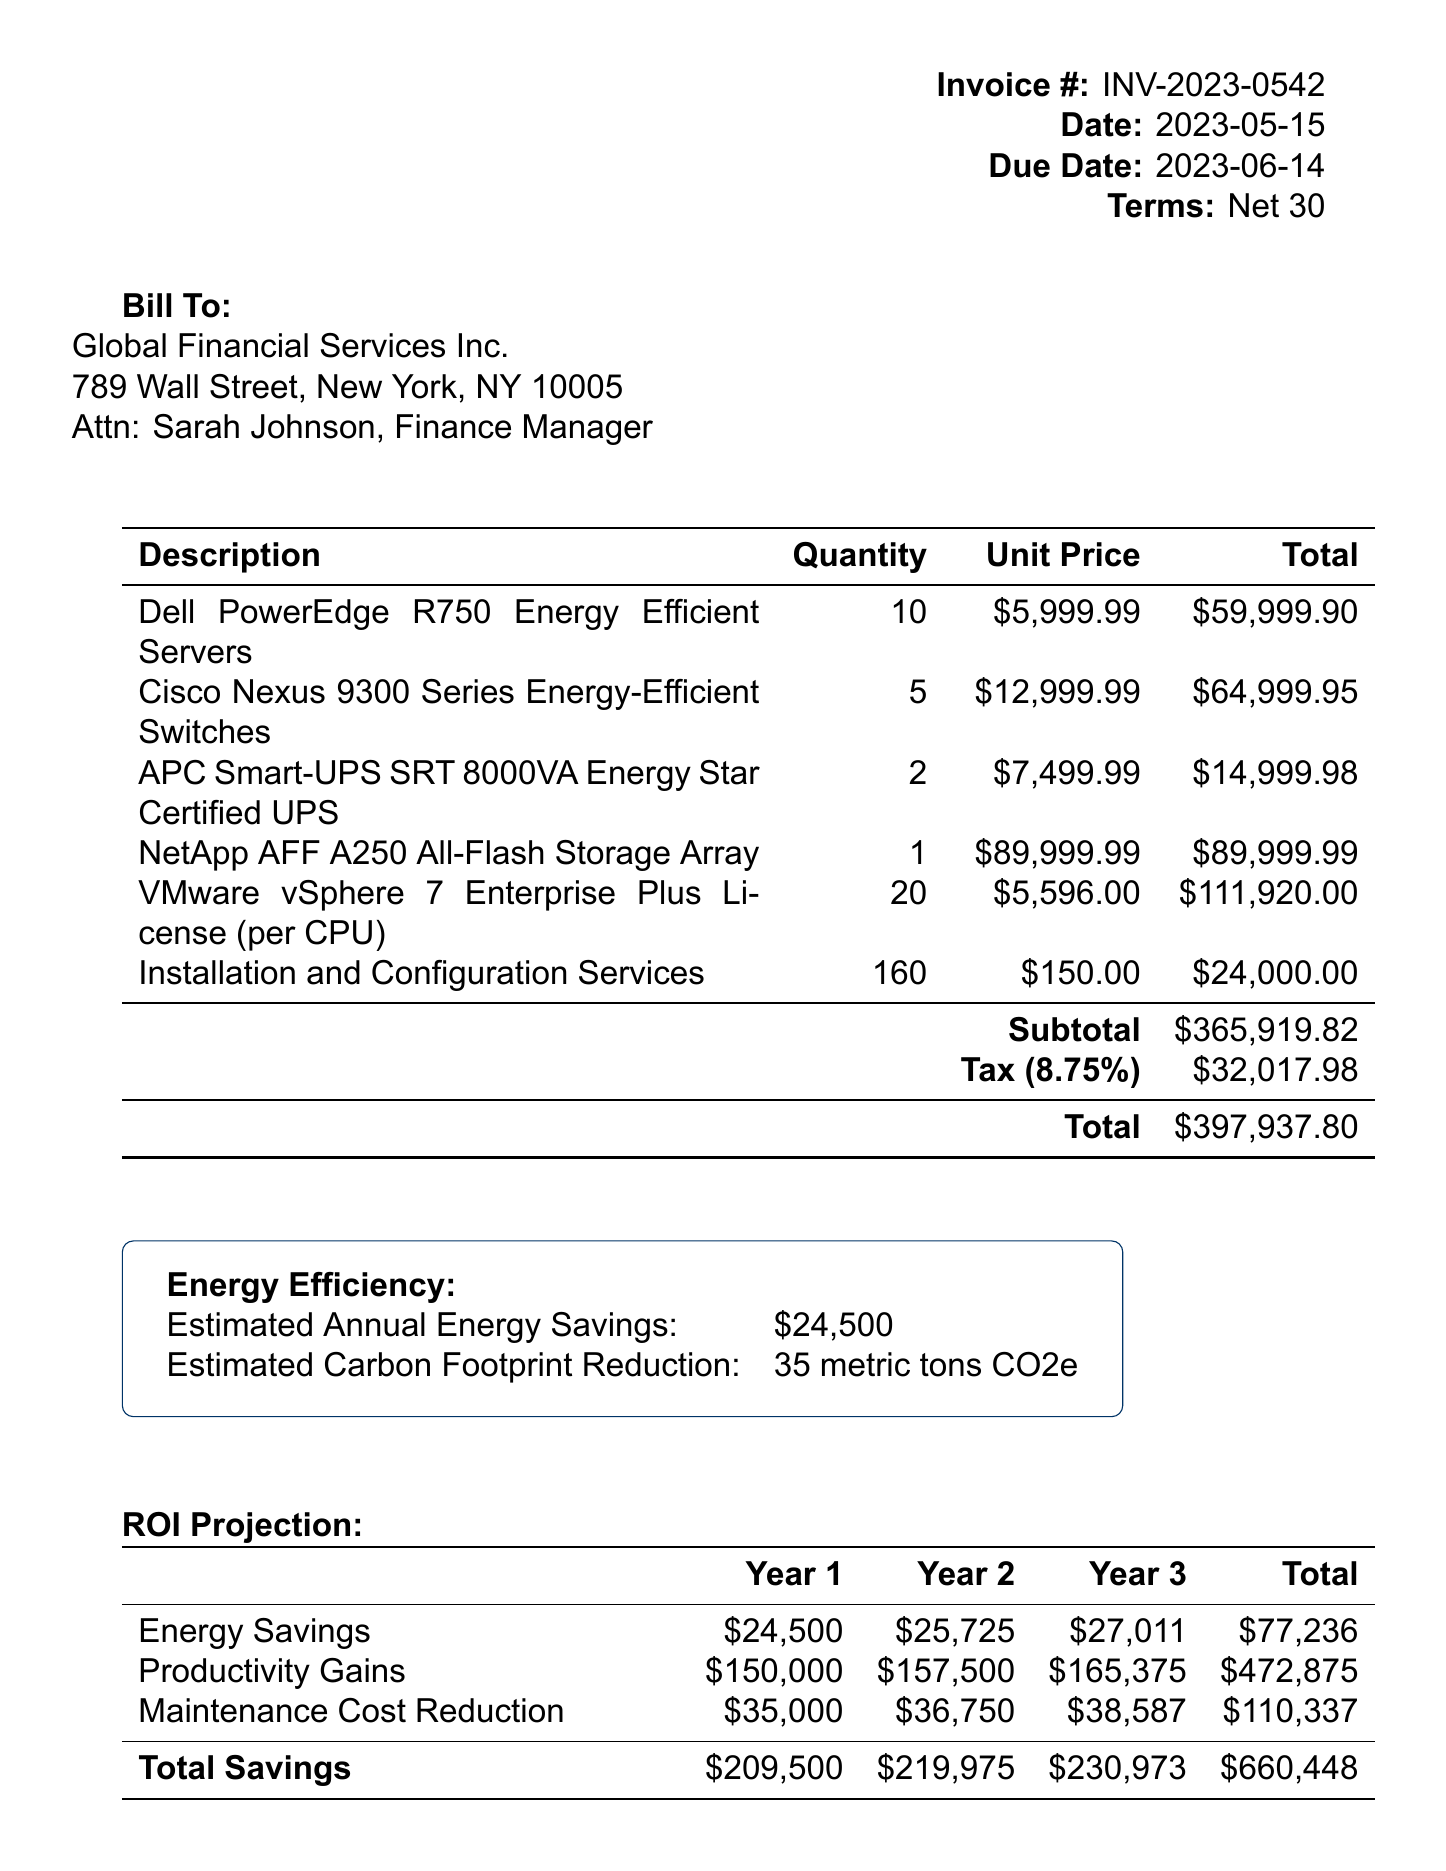What is the invoice number? The invoice number is found in the invoice details section.
Answer: INV-2023-0542 What is the subtotal amount? The subtotal amount is listed before tax and is part of the invoice details.
Answer: $365,919.82 Who is the contact person for the client? The contact person is specified along with the client's information.
Answer: Sarah Johnson, Finance Manager What is the tax rate? The tax rate is indicated in the invoice details section.
Answer: 8.75% What is the estimated annual energy savings? The energy efficiency details provide this estimate.
Answer: $24,500 What does the 3-year ROI percentage represent? The ROI percentage summarizes the return on investment over three years.
Answer: 66% How many energy-efficient switches are listed in the line items? The quantity of switches is specified in the line items table.
Answer: 5 What is included in the additional notes? The additional notes contain various comments regarding the upgrade.
Answer: This upgrade will significantly improve our digital auditing capabilities What are the payment instructions provided? The payment instructions section lists the bank details required for payment.
Answer: Bank Name: Silicon Valley Bank 